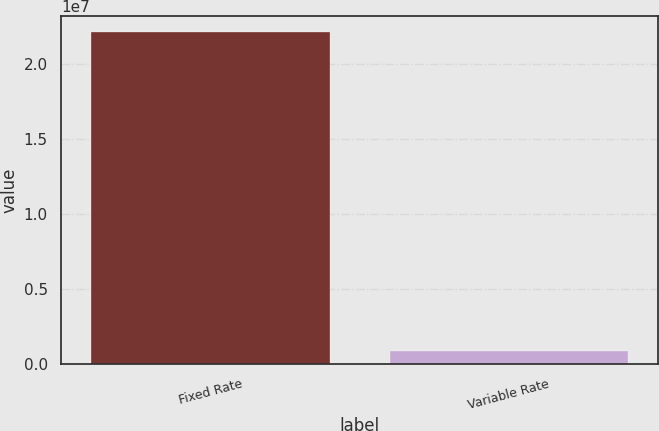Convert chart. <chart><loc_0><loc_0><loc_500><loc_500><bar_chart><fcel>Fixed Rate<fcel>Variable Rate<nl><fcel>2.20833e+07<fcel>893774<nl></chart> 